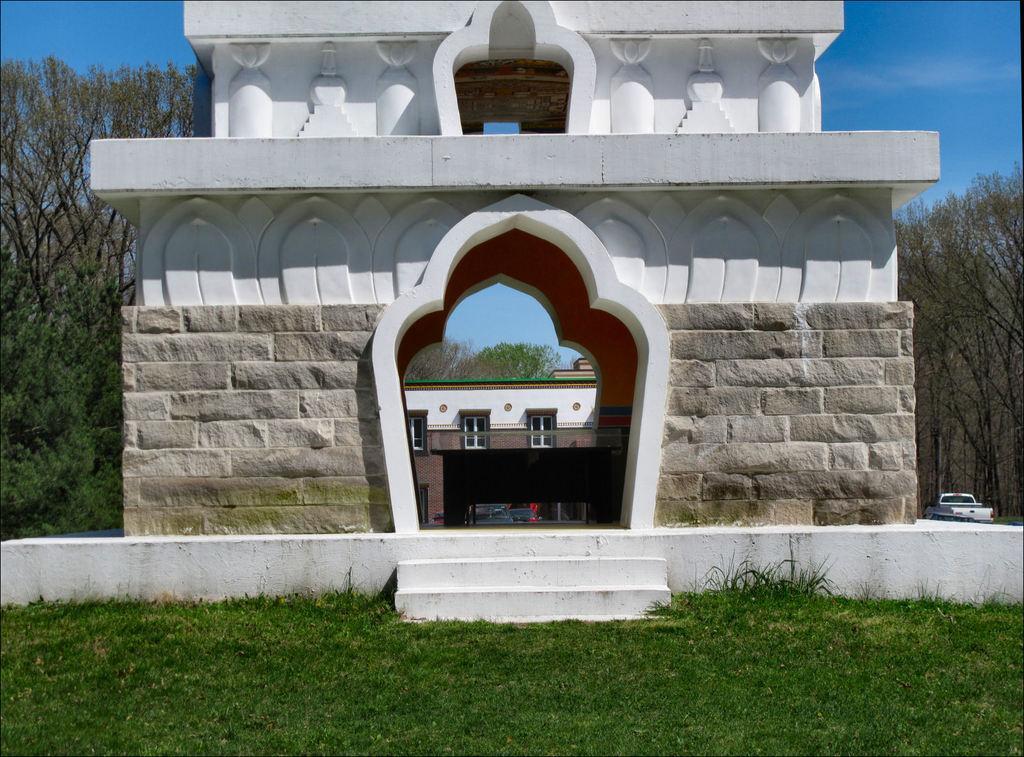Could you give a brief overview of what you see in this image? In the image in the center there is an arch and grass. In the background, we can see the sky, clouds, trees and one building. 